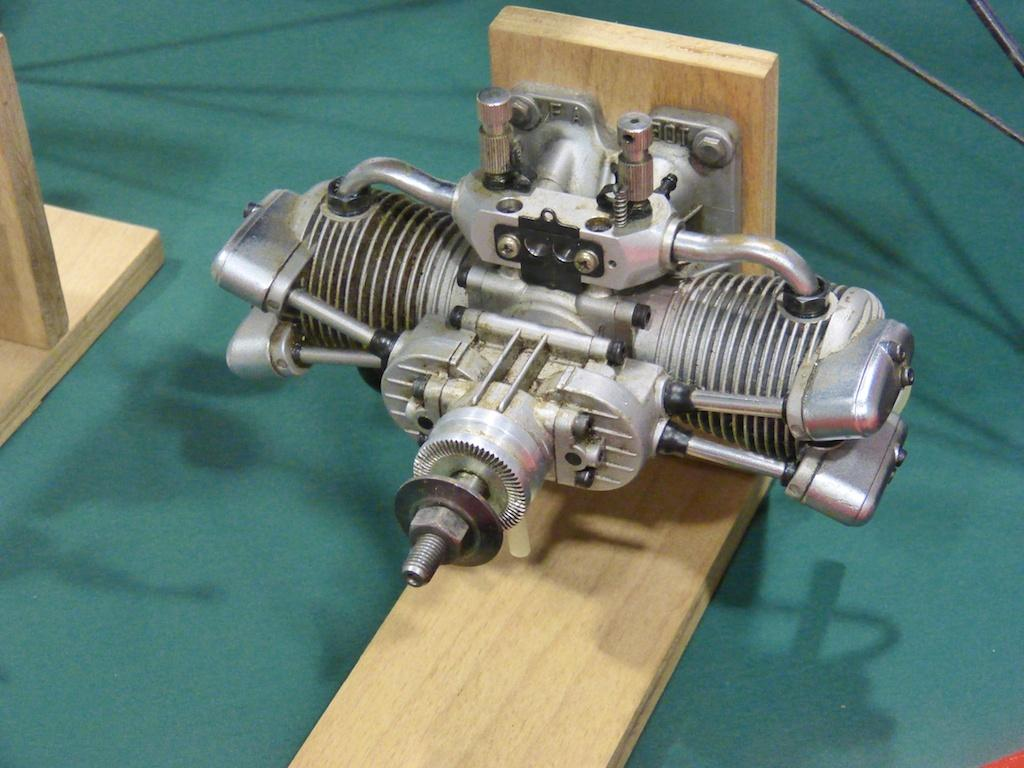What is the main object in the image? There is an engine in the image. How is the engine positioned in the image? The engine is placed on a wooden board. What else can be seen in the background of the image? There are cables visible in the background of the image. What type of noise is the engine making in the image? The image does not provide any information about the sound or noise made by the engine. 